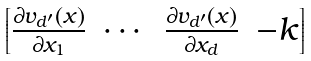<formula> <loc_0><loc_0><loc_500><loc_500>\begin{bmatrix} \frac { \partial v _ { d ^ { \prime } } ( x ) } { \partial x _ { 1 } } & \cdots & \frac { \partial v _ { d ^ { \prime } } ( x ) } { \partial x _ { d } } & - k \end{bmatrix}</formula> 